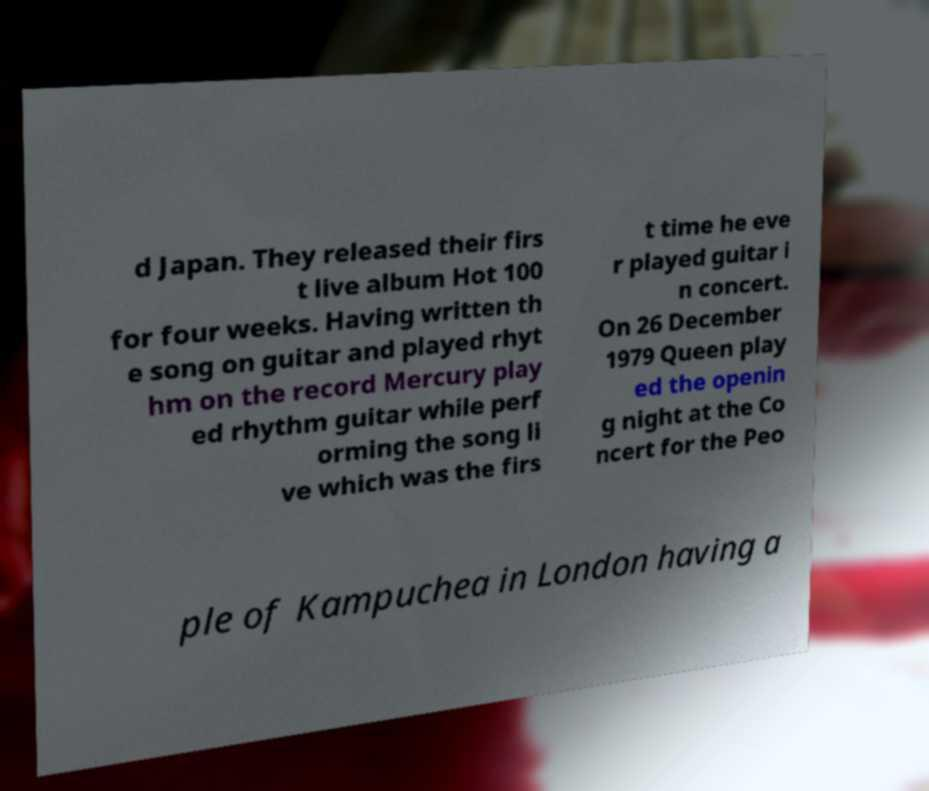Please read and relay the text visible in this image. What does it say? d Japan. They released their firs t live album Hot 100 for four weeks. Having written th e song on guitar and played rhyt hm on the record Mercury play ed rhythm guitar while perf orming the song li ve which was the firs t time he eve r played guitar i n concert. On 26 December 1979 Queen play ed the openin g night at the Co ncert for the Peo ple of Kampuchea in London having a 